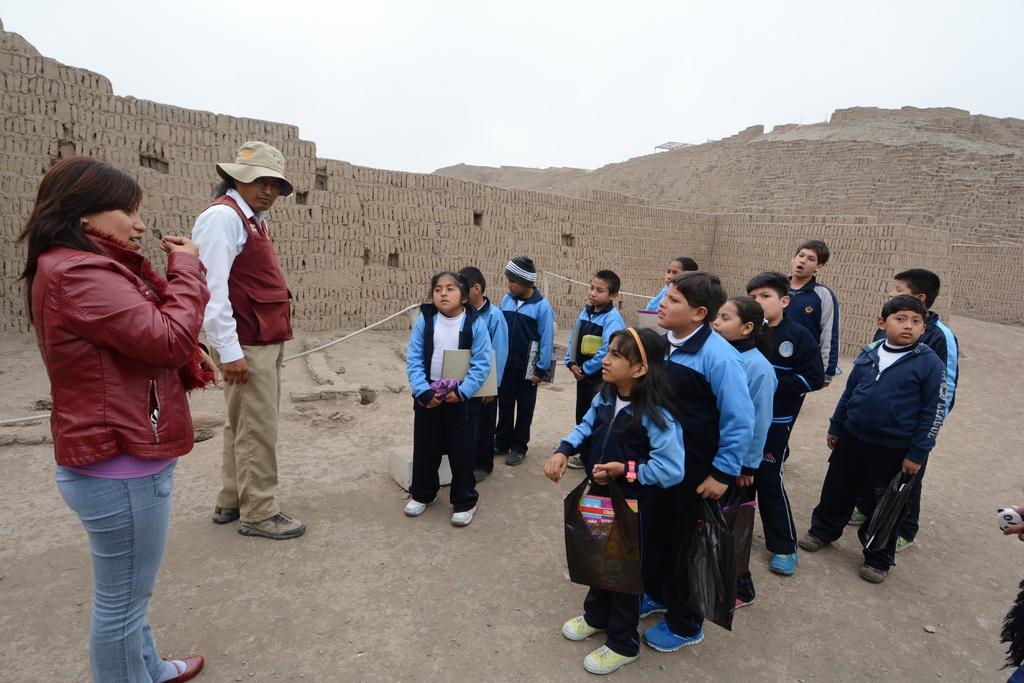Can you describe this image briefly? There is a man and a woman wearing jacket. Man is wearing a hat. Also there are many children holding packets and some other things. In the back there is a brick wall. Also there is sky. 